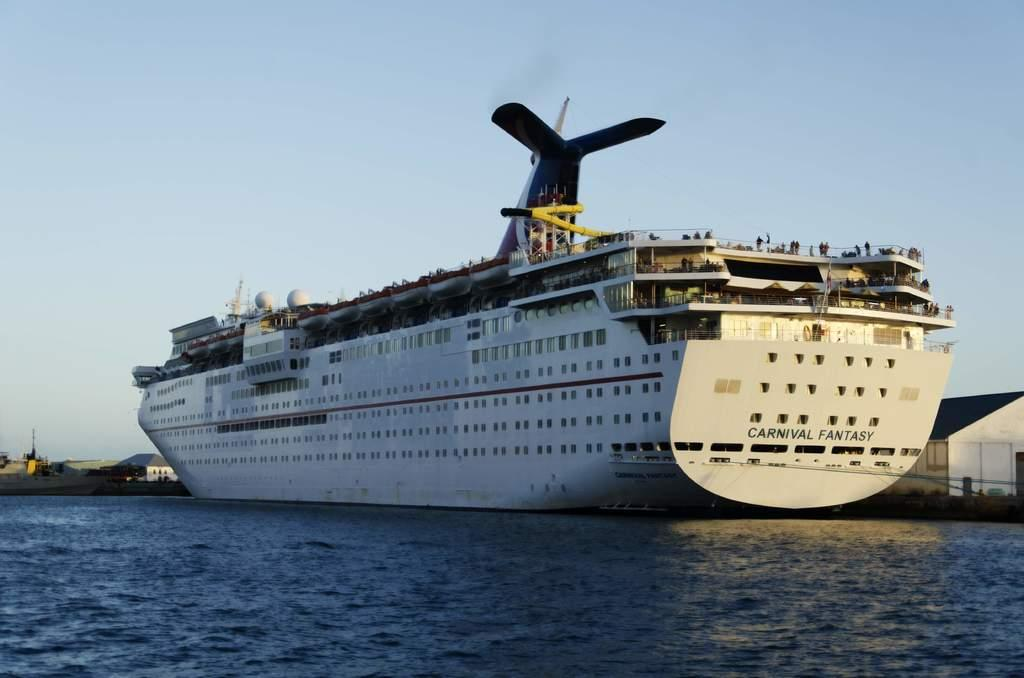<image>
Relay a brief, clear account of the picture shown. A cruise ship is sailing named Carnival Fantasy 